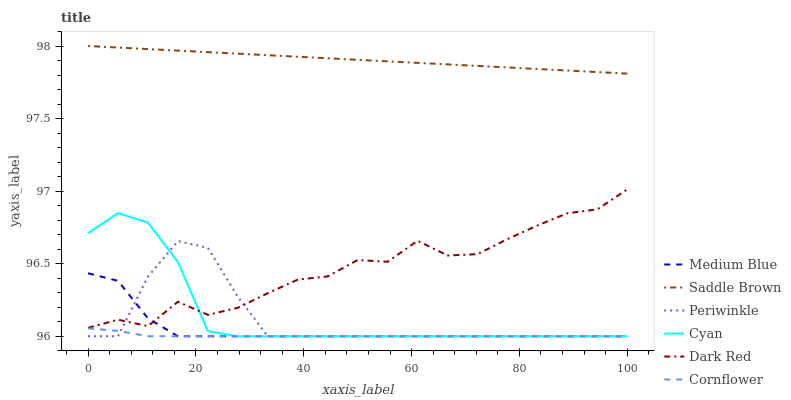Does Cornflower have the minimum area under the curve?
Answer yes or no. Yes. Does Saddle Brown have the maximum area under the curve?
Answer yes or no. Yes. Does Dark Red have the minimum area under the curve?
Answer yes or no. No. Does Dark Red have the maximum area under the curve?
Answer yes or no. No. Is Saddle Brown the smoothest?
Answer yes or no. Yes. Is Dark Red the roughest?
Answer yes or no. Yes. Is Medium Blue the smoothest?
Answer yes or no. No. Is Medium Blue the roughest?
Answer yes or no. No. Does Cornflower have the lowest value?
Answer yes or no. Yes. Does Dark Red have the lowest value?
Answer yes or no. No. Does Saddle Brown have the highest value?
Answer yes or no. Yes. Does Dark Red have the highest value?
Answer yes or no. No. Is Cornflower less than Dark Red?
Answer yes or no. Yes. Is Saddle Brown greater than Dark Red?
Answer yes or no. Yes. Does Dark Red intersect Medium Blue?
Answer yes or no. Yes. Is Dark Red less than Medium Blue?
Answer yes or no. No. Is Dark Red greater than Medium Blue?
Answer yes or no. No. Does Cornflower intersect Dark Red?
Answer yes or no. No. 